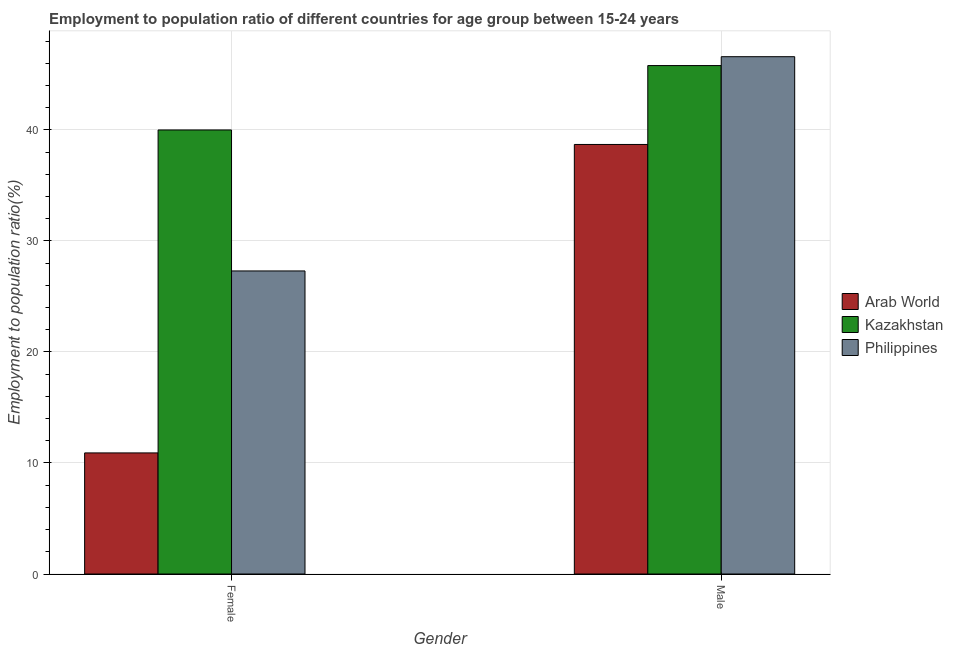How many groups of bars are there?
Make the answer very short. 2. Are the number of bars per tick equal to the number of legend labels?
Offer a terse response. Yes. Are the number of bars on each tick of the X-axis equal?
Offer a very short reply. Yes. Across all countries, what is the maximum employment to population ratio(male)?
Give a very brief answer. 46.6. Across all countries, what is the minimum employment to population ratio(female)?
Keep it short and to the point. 10.91. In which country was the employment to population ratio(male) minimum?
Make the answer very short. Arab World. What is the total employment to population ratio(female) in the graph?
Give a very brief answer. 78.21. What is the difference between the employment to population ratio(female) in Kazakhstan and that in Philippines?
Keep it short and to the point. 12.7. What is the difference between the employment to population ratio(male) in Kazakhstan and the employment to population ratio(female) in Philippines?
Offer a very short reply. 18.5. What is the average employment to population ratio(female) per country?
Your response must be concise. 26.07. What is the difference between the employment to population ratio(male) and employment to population ratio(female) in Kazakhstan?
Provide a short and direct response. 5.8. In how many countries, is the employment to population ratio(female) greater than 34 %?
Your answer should be very brief. 1. What is the ratio of the employment to population ratio(male) in Kazakhstan to that in Philippines?
Ensure brevity in your answer.  0.98. Is the employment to population ratio(male) in Kazakhstan less than that in Arab World?
Offer a terse response. No. In how many countries, is the employment to population ratio(female) greater than the average employment to population ratio(female) taken over all countries?
Your answer should be compact. 2. What does the 3rd bar from the left in Female represents?
Provide a succinct answer. Philippines. What does the 2nd bar from the right in Male represents?
Offer a very short reply. Kazakhstan. How many bars are there?
Your answer should be very brief. 6. Are all the bars in the graph horizontal?
Make the answer very short. No. What is the difference between two consecutive major ticks on the Y-axis?
Ensure brevity in your answer.  10. Are the values on the major ticks of Y-axis written in scientific E-notation?
Provide a succinct answer. No. Where does the legend appear in the graph?
Give a very brief answer. Center right. How are the legend labels stacked?
Offer a very short reply. Vertical. What is the title of the graph?
Make the answer very short. Employment to population ratio of different countries for age group between 15-24 years. What is the label or title of the X-axis?
Your answer should be very brief. Gender. What is the label or title of the Y-axis?
Provide a succinct answer. Employment to population ratio(%). What is the Employment to population ratio(%) in Arab World in Female?
Keep it short and to the point. 10.91. What is the Employment to population ratio(%) in Kazakhstan in Female?
Ensure brevity in your answer.  40. What is the Employment to population ratio(%) of Philippines in Female?
Your response must be concise. 27.3. What is the Employment to population ratio(%) in Arab World in Male?
Your answer should be compact. 38.69. What is the Employment to population ratio(%) of Kazakhstan in Male?
Keep it short and to the point. 45.8. What is the Employment to population ratio(%) in Philippines in Male?
Give a very brief answer. 46.6. Across all Gender, what is the maximum Employment to population ratio(%) of Arab World?
Offer a terse response. 38.69. Across all Gender, what is the maximum Employment to population ratio(%) of Kazakhstan?
Ensure brevity in your answer.  45.8. Across all Gender, what is the maximum Employment to population ratio(%) in Philippines?
Keep it short and to the point. 46.6. Across all Gender, what is the minimum Employment to population ratio(%) in Arab World?
Give a very brief answer. 10.91. Across all Gender, what is the minimum Employment to population ratio(%) of Philippines?
Keep it short and to the point. 27.3. What is the total Employment to population ratio(%) in Arab World in the graph?
Keep it short and to the point. 49.6. What is the total Employment to population ratio(%) of Kazakhstan in the graph?
Provide a succinct answer. 85.8. What is the total Employment to population ratio(%) of Philippines in the graph?
Your answer should be very brief. 73.9. What is the difference between the Employment to population ratio(%) of Arab World in Female and that in Male?
Ensure brevity in your answer.  -27.79. What is the difference between the Employment to population ratio(%) in Kazakhstan in Female and that in Male?
Give a very brief answer. -5.8. What is the difference between the Employment to population ratio(%) of Philippines in Female and that in Male?
Give a very brief answer. -19.3. What is the difference between the Employment to population ratio(%) in Arab World in Female and the Employment to population ratio(%) in Kazakhstan in Male?
Offer a terse response. -34.89. What is the difference between the Employment to population ratio(%) in Arab World in Female and the Employment to population ratio(%) in Philippines in Male?
Provide a short and direct response. -35.69. What is the average Employment to population ratio(%) of Arab World per Gender?
Offer a very short reply. 24.8. What is the average Employment to population ratio(%) in Kazakhstan per Gender?
Offer a very short reply. 42.9. What is the average Employment to population ratio(%) of Philippines per Gender?
Provide a short and direct response. 36.95. What is the difference between the Employment to population ratio(%) of Arab World and Employment to population ratio(%) of Kazakhstan in Female?
Give a very brief answer. -29.09. What is the difference between the Employment to population ratio(%) in Arab World and Employment to population ratio(%) in Philippines in Female?
Your response must be concise. -16.39. What is the difference between the Employment to population ratio(%) of Kazakhstan and Employment to population ratio(%) of Philippines in Female?
Ensure brevity in your answer.  12.7. What is the difference between the Employment to population ratio(%) of Arab World and Employment to population ratio(%) of Kazakhstan in Male?
Your answer should be compact. -7.11. What is the difference between the Employment to population ratio(%) in Arab World and Employment to population ratio(%) in Philippines in Male?
Offer a terse response. -7.91. What is the ratio of the Employment to population ratio(%) in Arab World in Female to that in Male?
Offer a very short reply. 0.28. What is the ratio of the Employment to population ratio(%) in Kazakhstan in Female to that in Male?
Provide a succinct answer. 0.87. What is the ratio of the Employment to population ratio(%) in Philippines in Female to that in Male?
Give a very brief answer. 0.59. What is the difference between the highest and the second highest Employment to population ratio(%) in Arab World?
Keep it short and to the point. 27.79. What is the difference between the highest and the second highest Employment to population ratio(%) of Kazakhstan?
Keep it short and to the point. 5.8. What is the difference between the highest and the second highest Employment to population ratio(%) of Philippines?
Give a very brief answer. 19.3. What is the difference between the highest and the lowest Employment to population ratio(%) of Arab World?
Your answer should be compact. 27.79. What is the difference between the highest and the lowest Employment to population ratio(%) in Philippines?
Your answer should be compact. 19.3. 